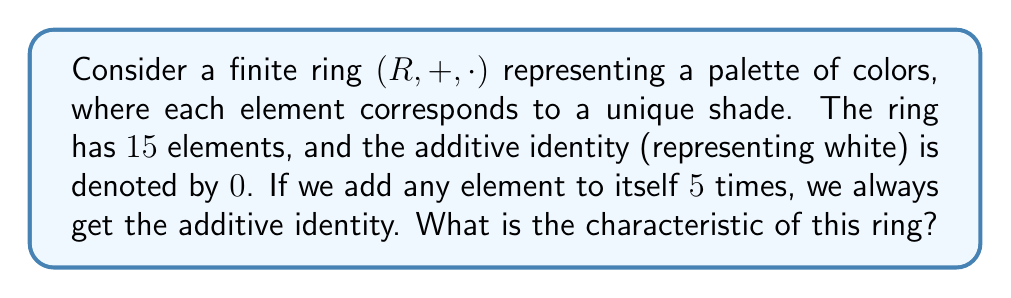Solve this math problem. To find the characteristic of a finite ring, we need to determine the smallest positive integer $n$ such that $n \cdot a = 0$ for all elements $a$ in the ring, where $0$ is the additive identity.

Given information:
1. The ring has $15$ elements.
2. Adding any element to itself $5$ times results in the additive identity.

Let's approach this step-by-step:

1. For any element $a$ in the ring:
   $\underbrace{a + a + a + a + a}_{5 \text{ times}} = 0$

2. In ring notation, this can be written as:
   $5a = 0$ for all $a$ in $R$

3. This means that the characteristic of the ring is a divisor of $5$.

4. The possible divisors of $5$ are $1$ and $5$.

5. If the characteristic were $1$, then $1a = 0$ for all $a$, which would mean all elements are $0$. This contradicts the fact that the ring has $15$ elements.

6. Therefore, the characteristic must be $5$.

To verify:
- For any $a$ in $R$: $5a = 0$
- For any integer $k < 5$: $ka \neq 0$ for at least some $a$ in $R$

Thus, $5$ is the smallest positive integer that satisfies the definition of characteristic for all elements in the ring.
Answer: The characteristic of the ring is $5$. 